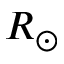Convert formula to latex. <formula><loc_0><loc_0><loc_500><loc_500>R _ { \odot }</formula> 